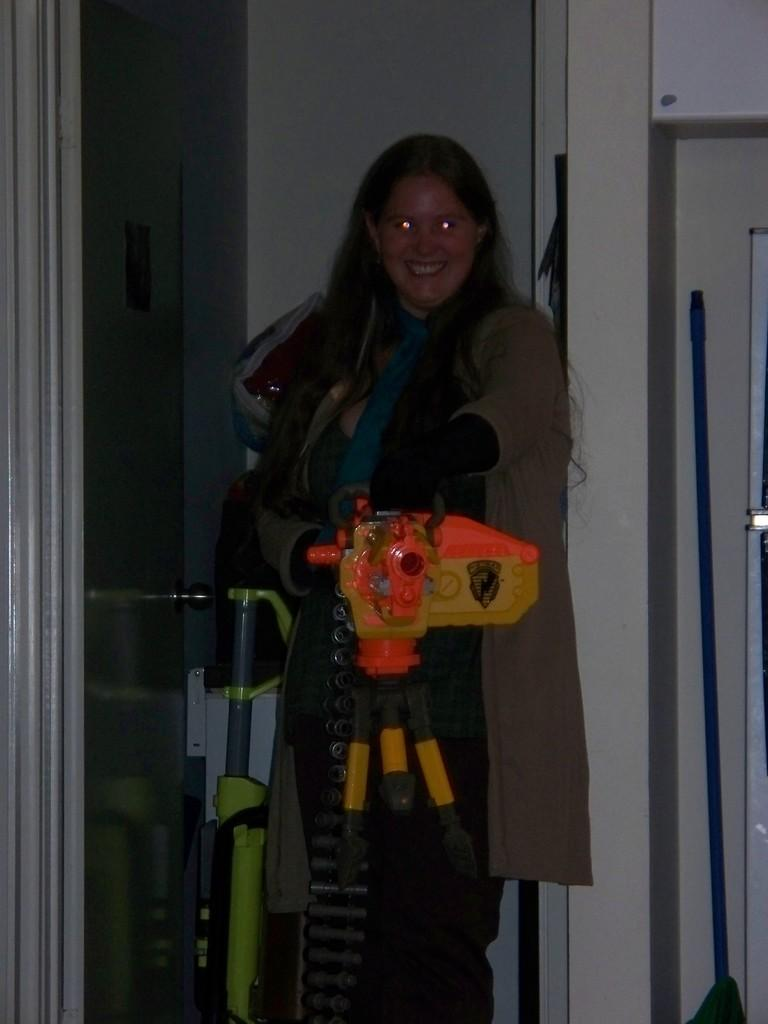Who is present in the image? There is a woman in the image. Can you describe the woman's appearance? The woman has long hair and is wearing a brown coat. What is the woman holding in her hand? The woman is holding a toy in her hand. What can be seen in the background of the image? There is a stick and a door in the background of the image. What type of zinc is present in the image? There is no zinc present in the image. Is there a collar visible on the woman in the image? The provided facts do not mention a collar, so we cannot determine if there is one present. 